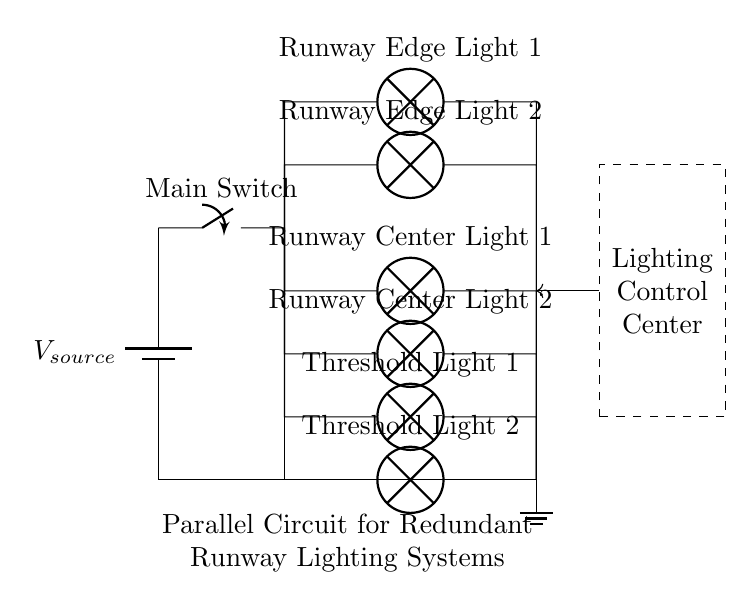What is the power source type in this circuit? The power source is labeled as a battery, which is indicated by the symbol in the circuit diagram.
Answer: Battery How many runway edge lights are present? The diagram shows two instances of the component labeled as "Runway Edge Light," meaning there are two of these lights in the circuit.
Answer: Two What is the total number of lights in the circuit? Counting the total labels in the diagram, there are two runway edge lights, two runway center lights, and two threshold lights, making a total of six lights.
Answer: Six What type of circuit is represented in the diagram? The circuit is structured so that all lights are connected in parallel, as indicated by the multiple branches stemming from a single point.
Answer: Parallel Why is a parallel circuit advantageous for runway lighting systems? A parallel circuit allows each light to operate independently; if one light fails, the others continue to function, which is crucial for runway safety.
Answer: Independent operation Where is the control center located in relation to the circuit? The control center is shown outside the main circuit area, indicated by a dashed rectangle, positioned to the right of the lighting system.
Answer: To the right What is the purpose of the main switch in this circuit? The main switch serves to control the overall operation of the circuit, either allowing power to flow to the lights or disconnecting them entirely for maintenance or emergency.
Answer: Control operation 